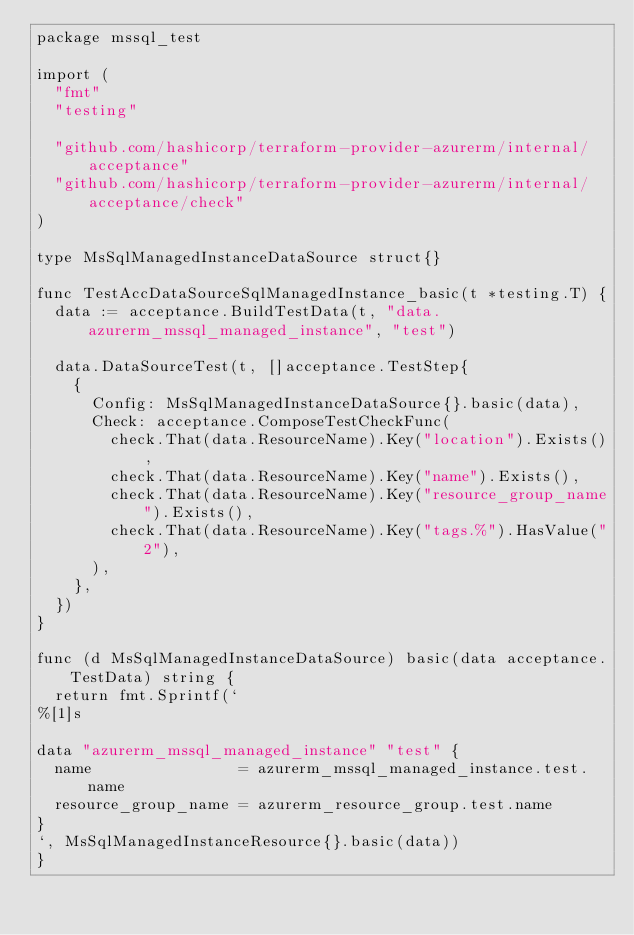<code> <loc_0><loc_0><loc_500><loc_500><_Go_>package mssql_test

import (
	"fmt"
	"testing"

	"github.com/hashicorp/terraform-provider-azurerm/internal/acceptance"
	"github.com/hashicorp/terraform-provider-azurerm/internal/acceptance/check"
)

type MsSqlManagedInstanceDataSource struct{}

func TestAccDataSourceSqlManagedInstance_basic(t *testing.T) {
	data := acceptance.BuildTestData(t, "data.azurerm_mssql_managed_instance", "test")

	data.DataSourceTest(t, []acceptance.TestStep{
		{
			Config: MsSqlManagedInstanceDataSource{}.basic(data),
			Check: acceptance.ComposeTestCheckFunc(
				check.That(data.ResourceName).Key("location").Exists(),
				check.That(data.ResourceName).Key("name").Exists(),
				check.That(data.ResourceName).Key("resource_group_name").Exists(),
				check.That(data.ResourceName).Key("tags.%").HasValue("2"),
			),
		},
	})
}

func (d MsSqlManagedInstanceDataSource) basic(data acceptance.TestData) string {
	return fmt.Sprintf(`
%[1]s

data "azurerm_mssql_managed_instance" "test" {
  name                = azurerm_mssql_managed_instance.test.name
  resource_group_name = azurerm_resource_group.test.name
}
`, MsSqlManagedInstanceResource{}.basic(data))
}
</code> 